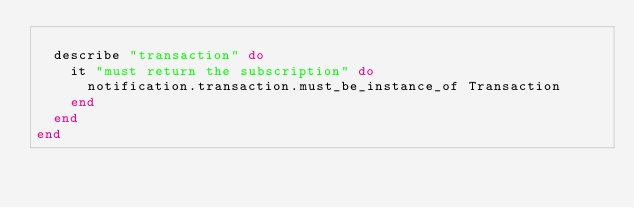<code> <loc_0><loc_0><loc_500><loc_500><_Ruby_>  
  describe "transaction" do
    it "must return the subscription" do
      notification.transaction.must_be_instance_of Transaction
    end
  end
end
</code> 